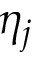<formula> <loc_0><loc_0><loc_500><loc_500>\eta _ { j }</formula> 